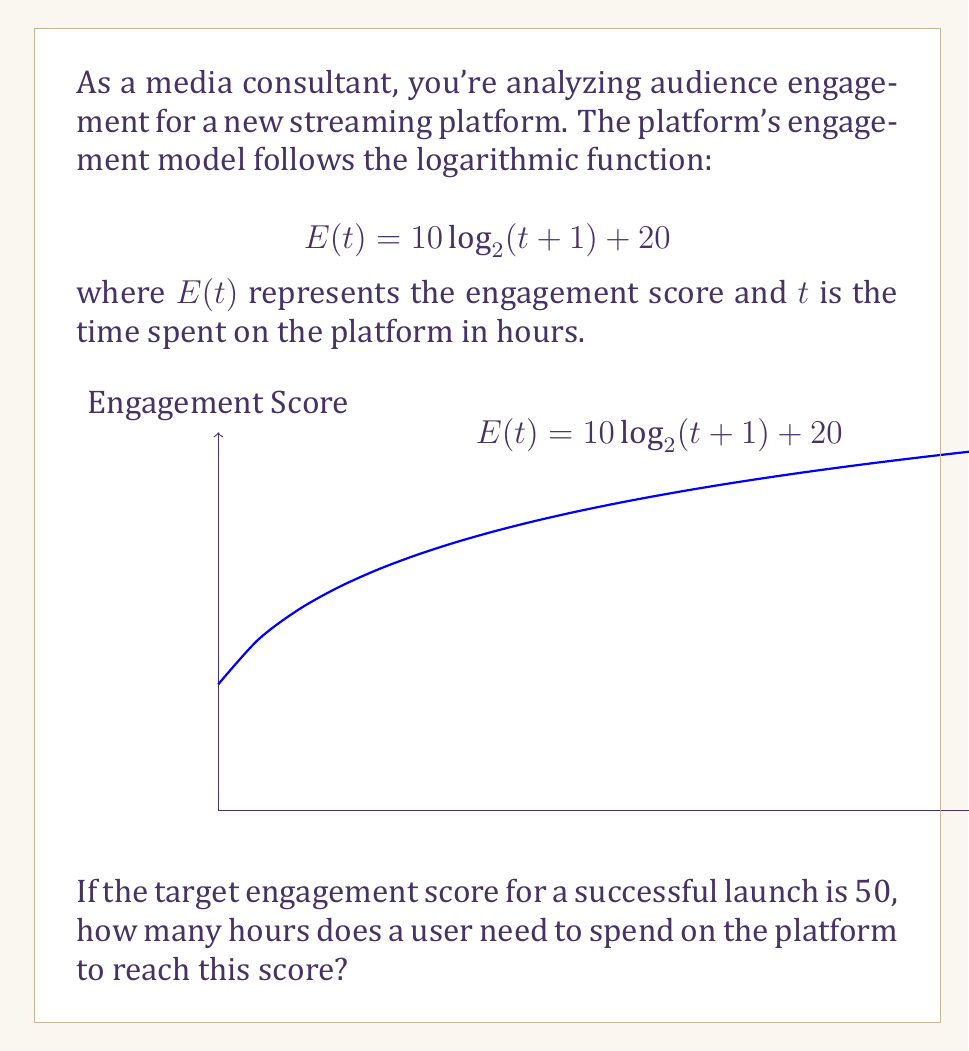Show me your answer to this math problem. Let's approach this step-by-step:

1) We're given the engagement function:
   $$E(t) = 10 \log_2(t+1) + 20$$

2) We want to find $t$ when $E(t) = 50$. So, let's set up the equation:
   $$50 = 10 \log_2(t+1) + 20$$

3) Subtract 20 from both sides:
   $$30 = 10 \log_2(t+1)$$

4) Divide both sides by 10:
   $$3 = \log_2(t+1)$$

5) To solve for $t$, we need to apply the inverse function of $\log_2$, which is $2^x$:
   $$2^3 = t+1$$

6) Simplify:
   $$8 = t+1$$

7) Subtract 1 from both sides:
   $$7 = t$$

Therefore, a user needs to spend 7 hours on the platform to reach an engagement score of 50.
Answer: 7 hours 